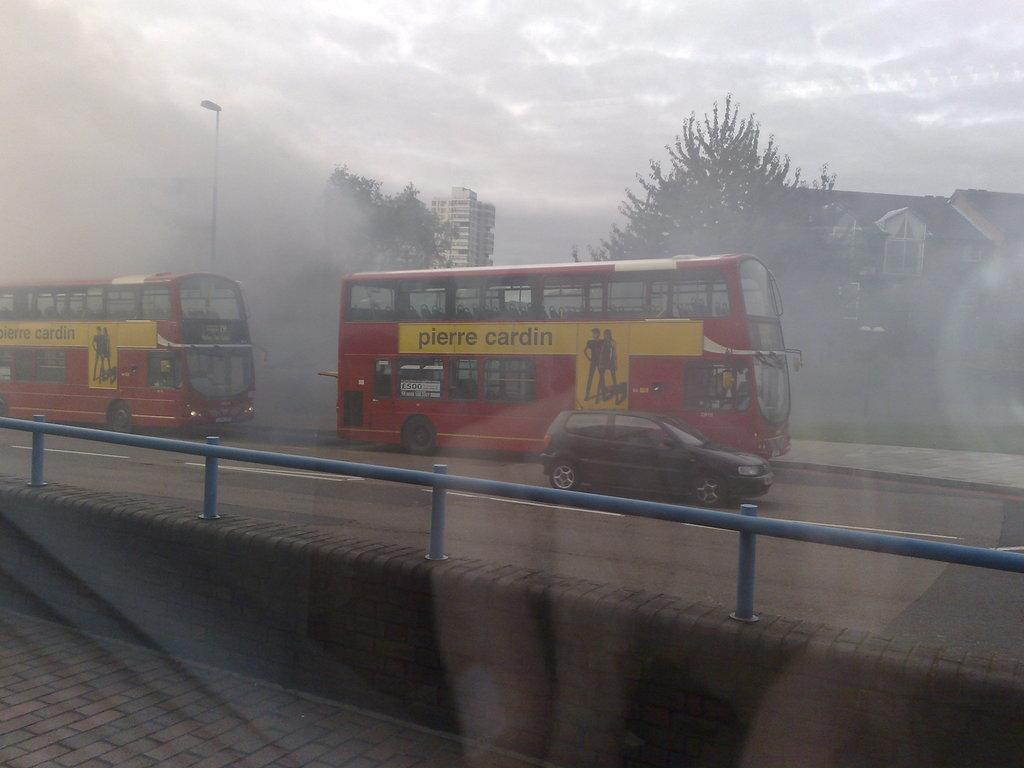<image>
Write a terse but informative summary of the picture. Double Decker bus with yellow stripe that reads pierre cardin driving in the rain. 